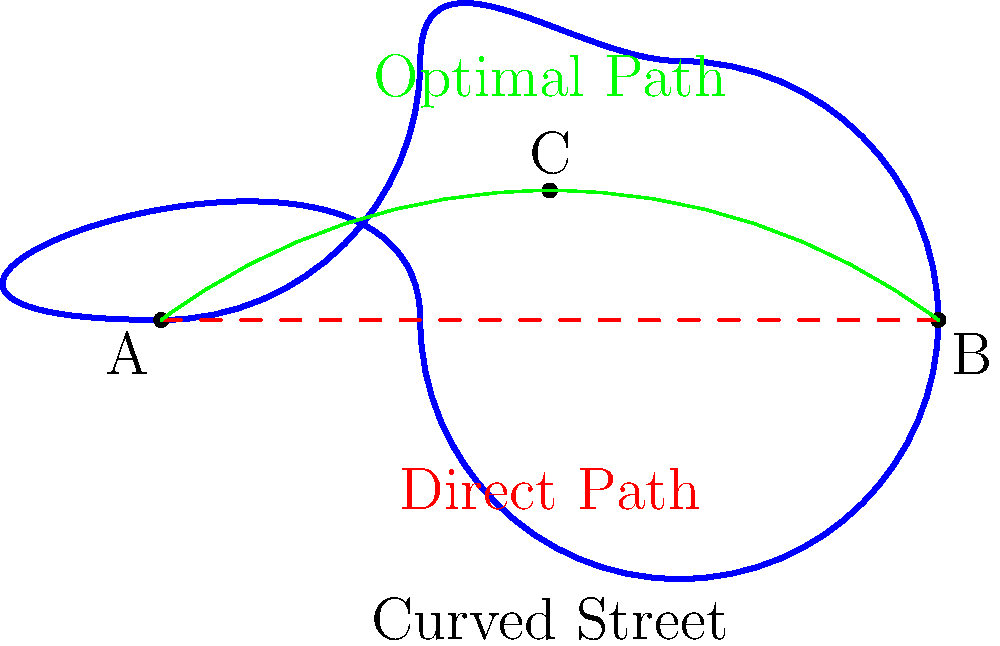In a historic city center with winding streets, a tourist wants to travel from point A to point B. The direct Euclidean path is not possible due to buildings. Using principles of non-Euclidean geometry, which path would likely be the shortest and most efficient for the tourist to take?

a) The curved street following the blue path
b) The direct path shown by the red dashed line
c) The green curved path passing through point C
d) A straight line path not shown on the diagram

How does this relate to promoting tourism in historic city centers with complex street layouts? To answer this question, we need to consider the principles of non-Euclidean geometry and how they apply to navigating curved spaces:

1. In Euclidean geometry, the shortest path between two points is always a straight line. However, in non-Euclidean geometry (such as on curved surfaces), this is not always true.

2. The red dashed line represents the Euclidean shortest path, but it's not possible to follow due to the buildings in the historic city center.

3. The blue curved path follows the street exactly, but it's longer and has more curvature than necessary.

4. The green path represents an optimal compromise between the direct path and the constraints of the city layout. It minimizes the distance traveled while adhering to the available routes.

5. In non-Euclidean spaces, geodesics (the equivalent of "straight lines") can be curved. The green path approximates a geodesic in this curved space.

6. Point C represents a strategic location where the path can change direction to optimize the route.

Relating this to promoting tourism:

- Understanding optimal paths in complex street layouts can help in creating better tourist maps and guides.
- It demonstrates the unique charm of historic cities, where the journey itself becomes part of the experience.
- This knowledge can be used to design walking tours that efficiently cover key attractions while showcasing the city's layout.
- It highlights the importance of local knowledge and can encourage tourists to engage with local guides or use specialized navigation tools.
Answer: c) The green curved path passing through point C 